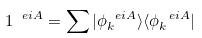Convert formula to latex. <formula><loc_0><loc_0><loc_500><loc_500>1 ^ { \ e i A } = \sum | \phi ^ { \ e i A } _ { k } \rangle \langle \phi ^ { \ e i A } _ { k } |</formula> 